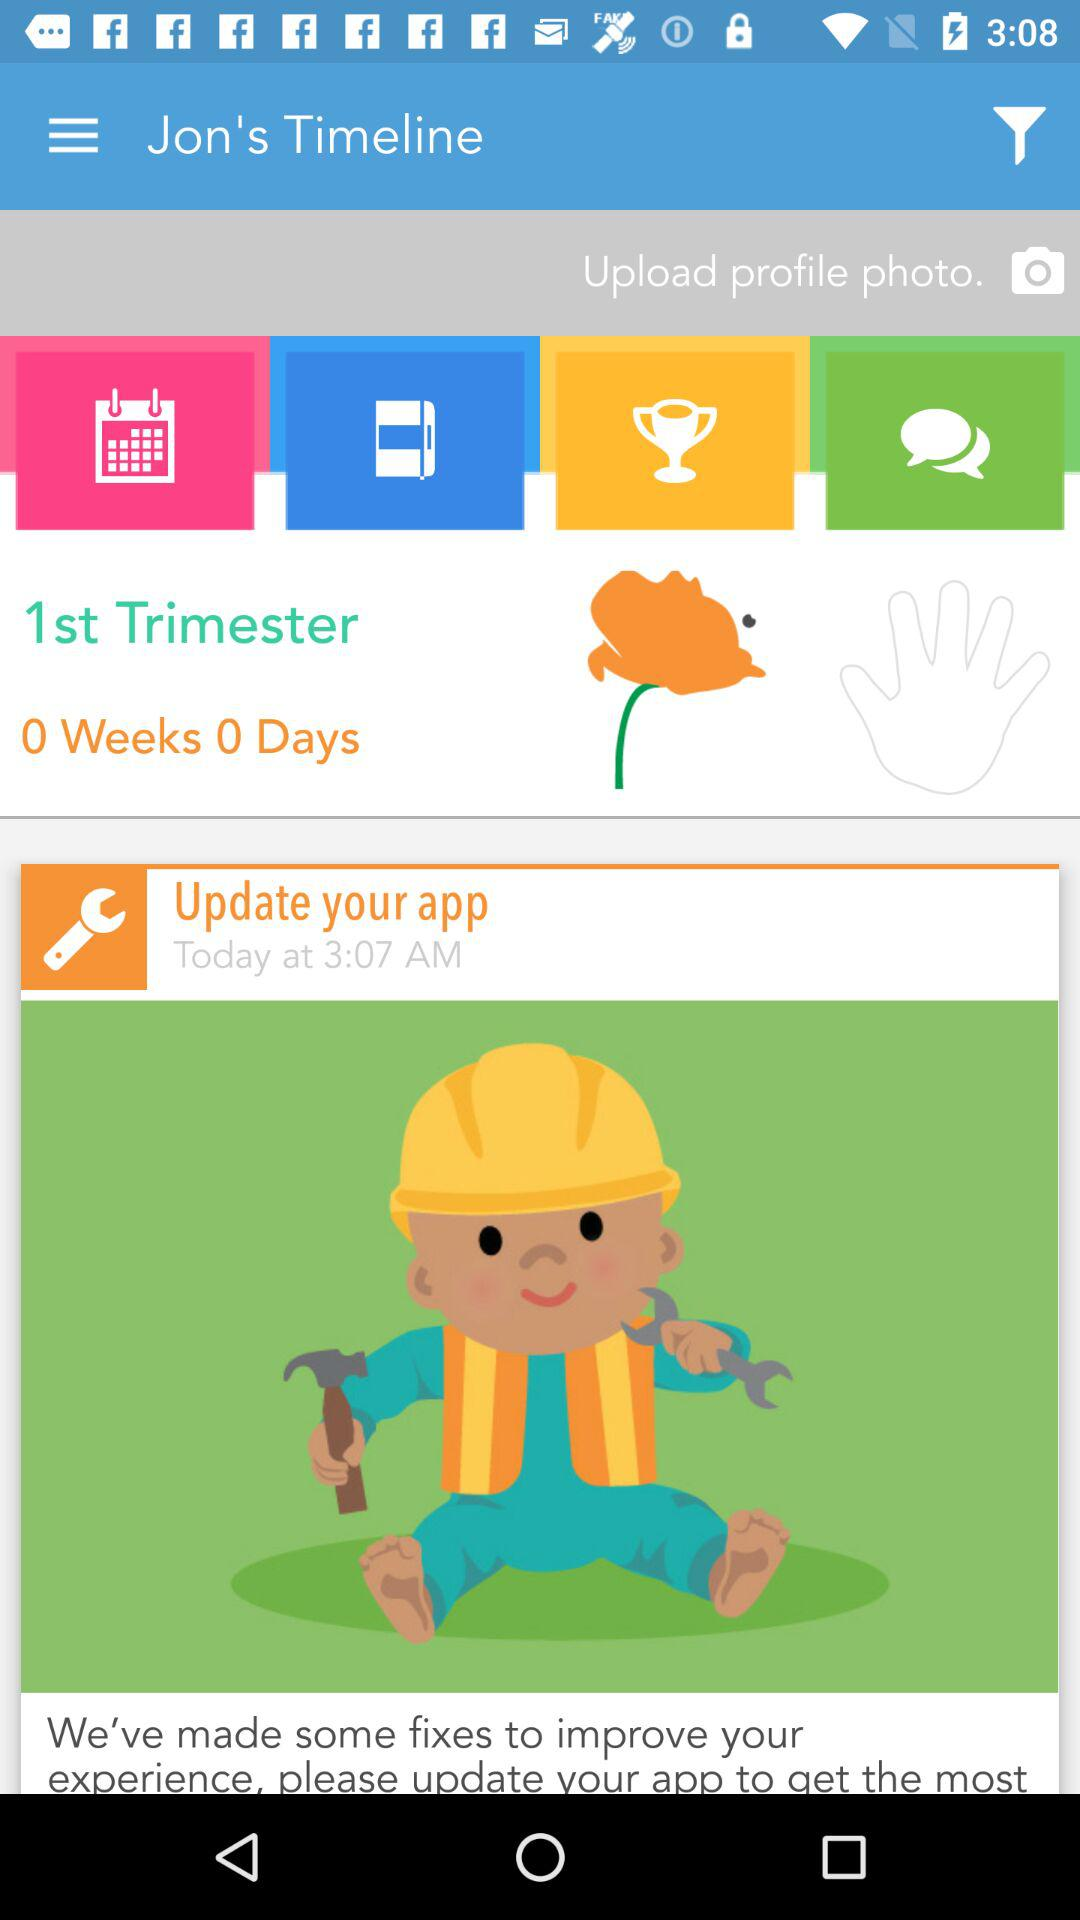When was the application last updated?
When the provided information is insufficient, respond with <no answer>. <no answer> 